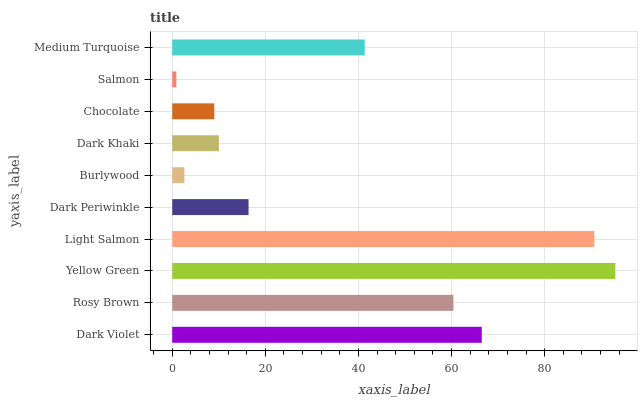Is Salmon the minimum?
Answer yes or no. Yes. Is Yellow Green the maximum?
Answer yes or no. Yes. Is Rosy Brown the minimum?
Answer yes or no. No. Is Rosy Brown the maximum?
Answer yes or no. No. Is Dark Violet greater than Rosy Brown?
Answer yes or no. Yes. Is Rosy Brown less than Dark Violet?
Answer yes or no. Yes. Is Rosy Brown greater than Dark Violet?
Answer yes or no. No. Is Dark Violet less than Rosy Brown?
Answer yes or no. No. Is Medium Turquoise the high median?
Answer yes or no. Yes. Is Dark Periwinkle the low median?
Answer yes or no. Yes. Is Dark Periwinkle the high median?
Answer yes or no. No. Is Dark Violet the low median?
Answer yes or no. No. 